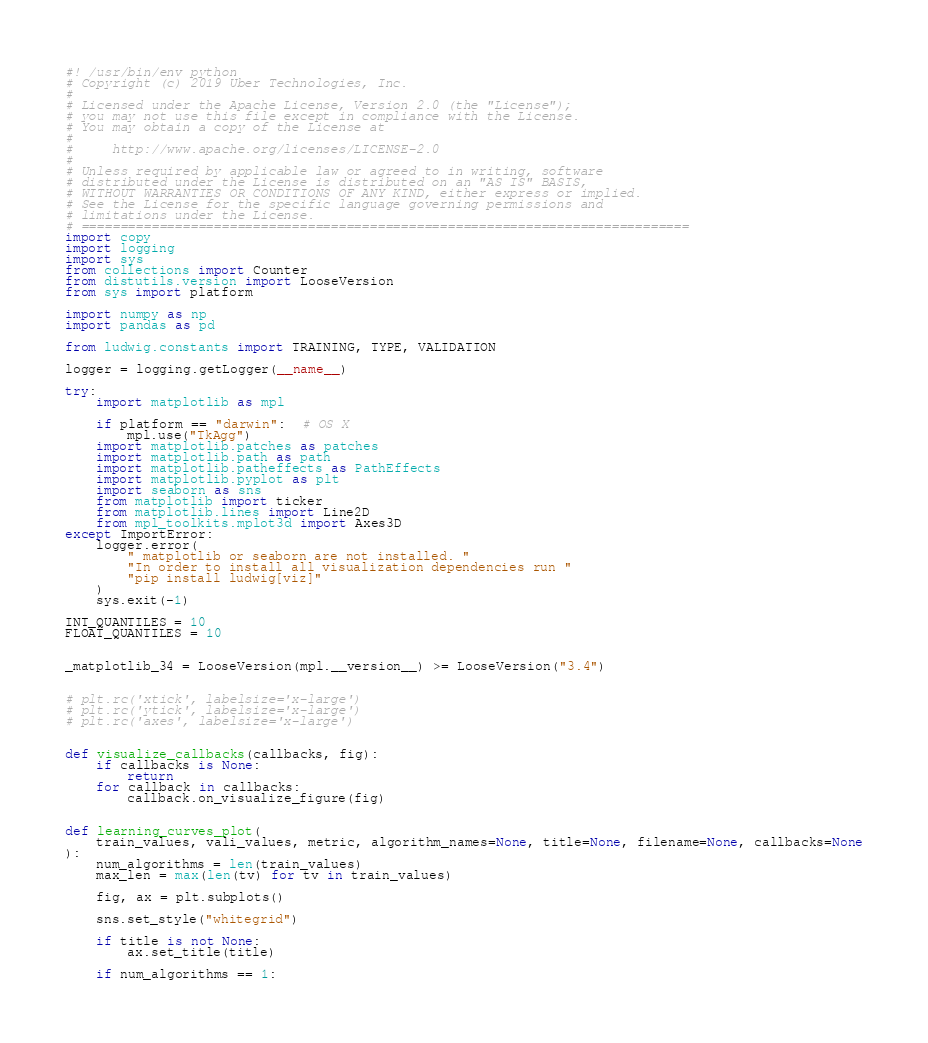<code> <loc_0><loc_0><loc_500><loc_500><_Python_>#! /usr/bin/env python
# Copyright (c) 2019 Uber Technologies, Inc.
#
# Licensed under the Apache License, Version 2.0 (the "License");
# you may not use this file except in compliance with the License.
# You may obtain a copy of the License at
#
#     http://www.apache.org/licenses/LICENSE-2.0
#
# Unless required by applicable law or agreed to in writing, software
# distributed under the License is distributed on an "AS IS" BASIS,
# WITHOUT WARRANTIES OR CONDITIONS OF ANY KIND, either express or implied.
# See the License for the specific language governing permissions and
# limitations under the License.
# ==============================================================================
import copy
import logging
import sys
from collections import Counter
from distutils.version import LooseVersion
from sys import platform

import numpy as np
import pandas as pd

from ludwig.constants import TRAINING, TYPE, VALIDATION

logger = logging.getLogger(__name__)

try:
    import matplotlib as mpl

    if platform == "darwin":  # OS X
        mpl.use("TkAgg")
    import matplotlib.patches as patches
    import matplotlib.path as path
    import matplotlib.patheffects as PathEffects
    import matplotlib.pyplot as plt
    import seaborn as sns
    from matplotlib import ticker
    from matplotlib.lines import Line2D
    from mpl_toolkits.mplot3d import Axes3D
except ImportError:
    logger.error(
        " matplotlib or seaborn are not installed. "
        "In order to install all visualization dependencies run "
        "pip install ludwig[viz]"
    )
    sys.exit(-1)

INT_QUANTILES = 10
FLOAT_QUANTILES = 10


_matplotlib_34 = LooseVersion(mpl.__version__) >= LooseVersion("3.4")


# plt.rc('xtick', labelsize='x-large')
# plt.rc('ytick', labelsize='x-large')
# plt.rc('axes', labelsize='x-large')


def visualize_callbacks(callbacks, fig):
    if callbacks is None:
        return
    for callback in callbacks:
        callback.on_visualize_figure(fig)


def learning_curves_plot(
    train_values, vali_values, metric, algorithm_names=None, title=None, filename=None, callbacks=None
):
    num_algorithms = len(train_values)
    max_len = max(len(tv) for tv in train_values)

    fig, ax = plt.subplots()

    sns.set_style("whitegrid")

    if title is not None:
        ax.set_title(title)

    if num_algorithms == 1:</code> 